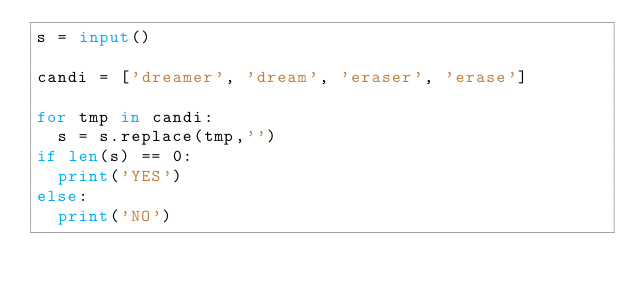<code> <loc_0><loc_0><loc_500><loc_500><_Python_>s = input()
 
candi = ['dreamer', 'dream', 'eraser', 'erase']
 
for tmp in candi:
  s = s.replace(tmp,'')
if len(s) == 0:
  print('YES')
else:
  print('NO')</code> 